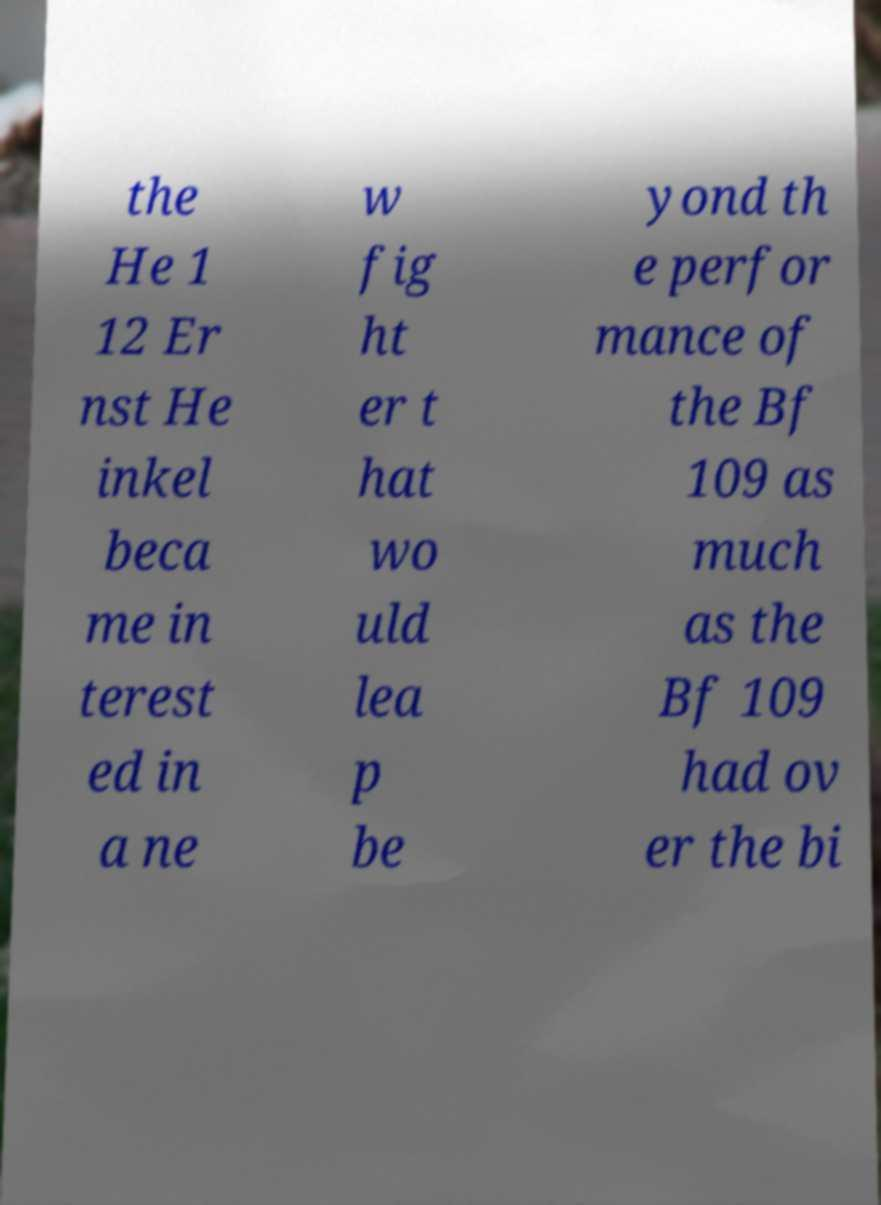Please read and relay the text visible in this image. What does it say? the He 1 12 Er nst He inkel beca me in terest ed in a ne w fig ht er t hat wo uld lea p be yond th e perfor mance of the Bf 109 as much as the Bf 109 had ov er the bi 